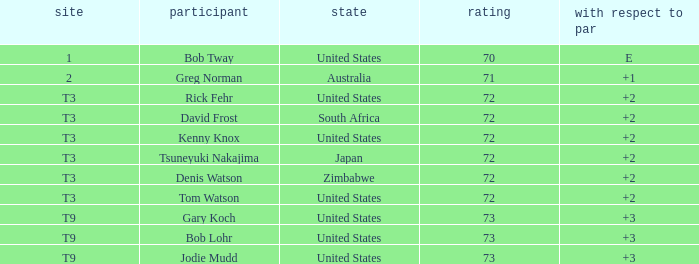What is the top score for tsuneyuki nakajima? 72.0. 